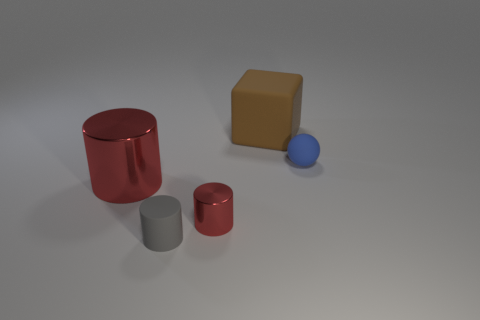Add 1 small cyan metallic balls. How many objects exist? 6 Subtract all blocks. How many objects are left? 4 Subtract all small gray metal cylinders. Subtract all large red metallic things. How many objects are left? 4 Add 5 tiny shiny cylinders. How many tiny shiny cylinders are left? 6 Add 3 purple matte balls. How many purple matte balls exist? 3 Subtract 0 brown cylinders. How many objects are left? 5 